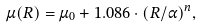<formula> <loc_0><loc_0><loc_500><loc_500>\mu ( R ) = \mu _ { 0 } + 1 . 0 8 6 \cdot ( R / \alpha ) ^ { n } ,</formula> 